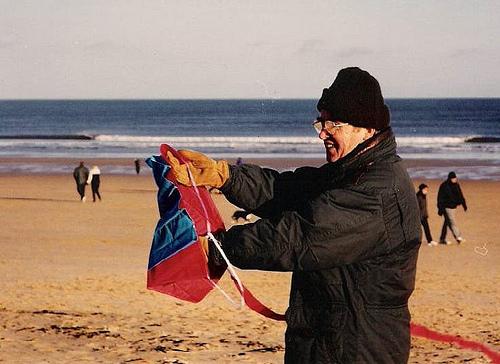Where is the man?
Give a very brief answer. Beach. Is this man happy?
Quick response, please. Yes. What is he holding in his hands?
Keep it brief. Kite. 